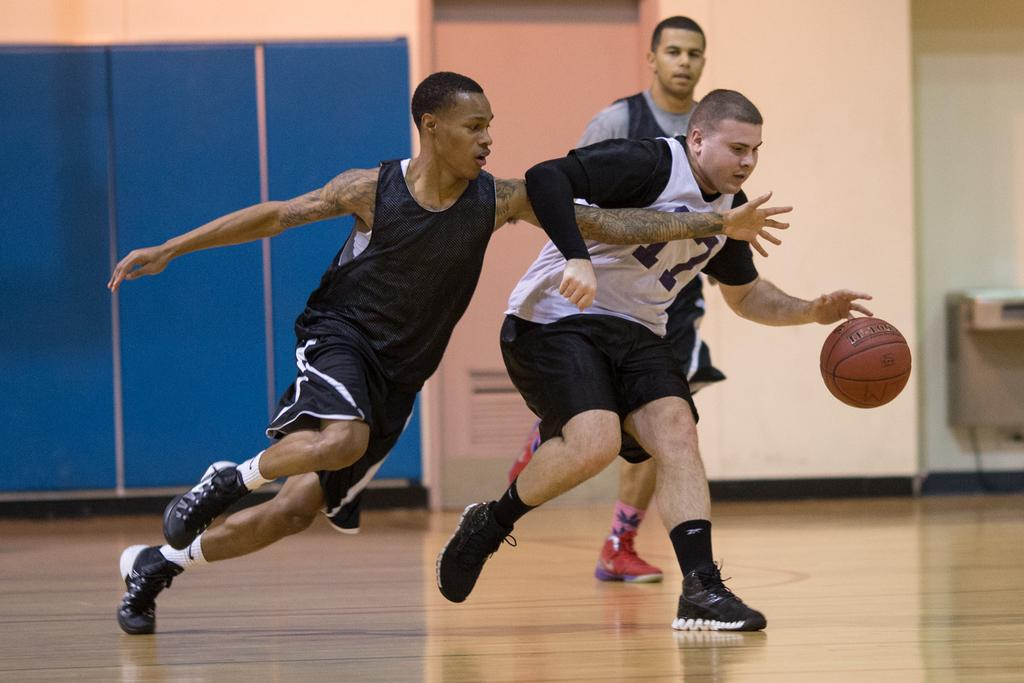What are the people in the image doing? The people in the image are standing on the floor. What object is in the air in the image? There is a basketball in the air in the image. What can be seen in the background of the image? There is a wall visible in the background of the image. What type of rose can be seen growing in the wilderness in the image? There is no rose or wilderness present in the image; it features people standing on the floor and a basketball in the air. 